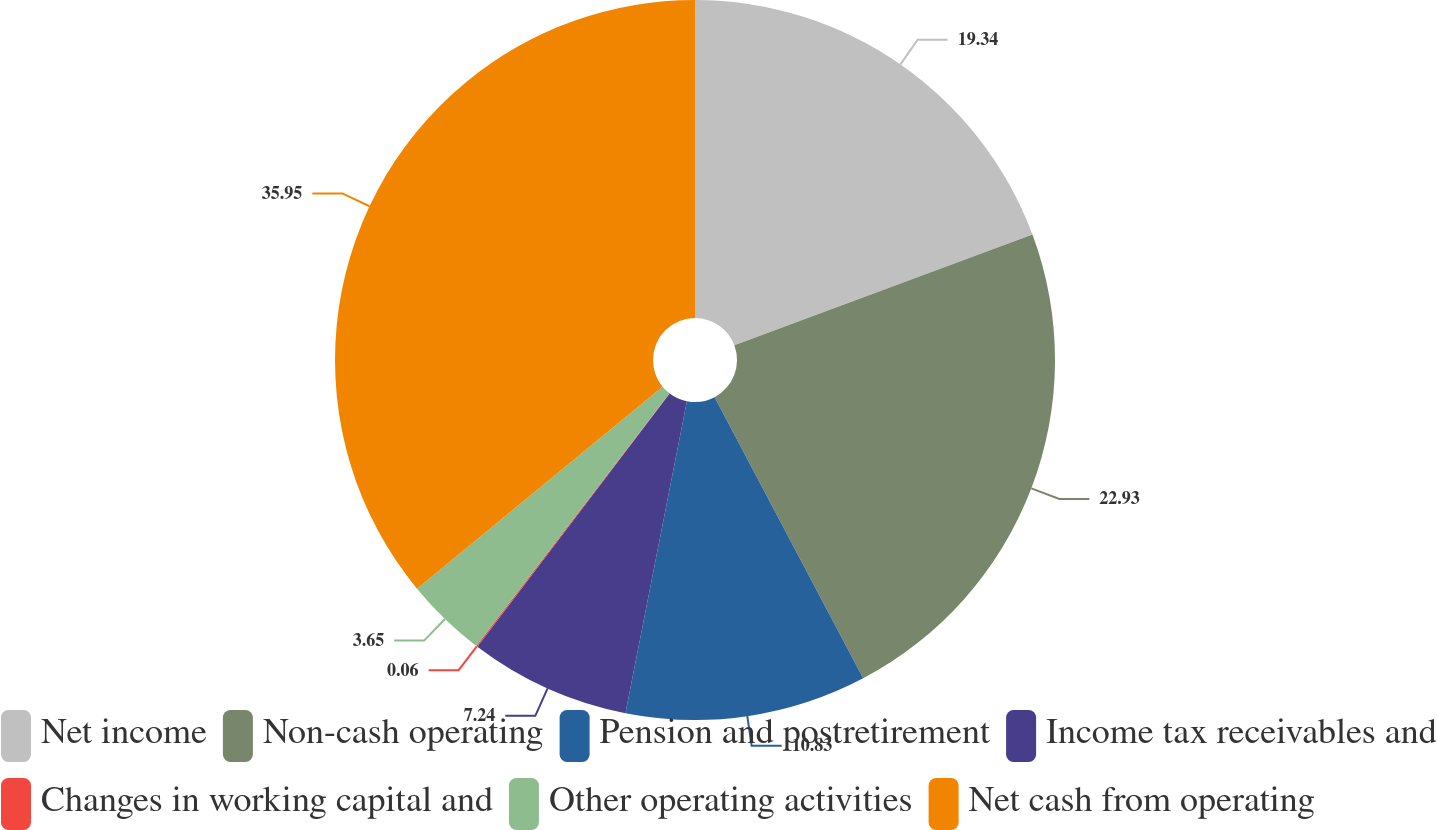Convert chart to OTSL. <chart><loc_0><loc_0><loc_500><loc_500><pie_chart><fcel>Net income<fcel>Non-cash operating<fcel>Pension and postretirement<fcel>Income tax receivables and<fcel>Changes in working capital and<fcel>Other operating activities<fcel>Net cash from operating<nl><fcel>19.34%<fcel>22.93%<fcel>10.83%<fcel>7.24%<fcel>0.06%<fcel>3.65%<fcel>35.96%<nl></chart> 